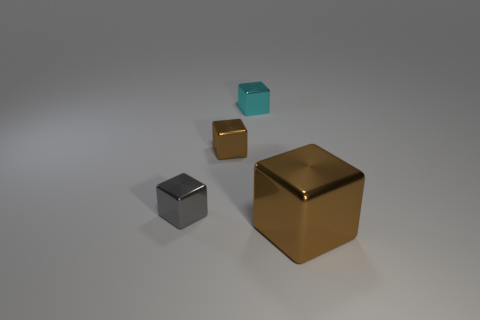What is the color of the cube that is both to the right of the tiny brown cube and behind the tiny gray cube?
Keep it short and to the point. Cyan. Are there any brown blocks of the same size as the gray thing?
Offer a very short reply. Yes. What size is the brown metal thing that is on the left side of the small thing that is behind the small brown metal cube?
Make the answer very short. Small. Are there fewer small brown objects on the right side of the cyan thing than large purple things?
Provide a short and direct response. No. How big is the cyan cube?
Make the answer very short. Small. How many other big objects are the same color as the large shiny thing?
Ensure brevity in your answer.  0. There is a brown metal block that is left of the brown block in front of the gray shiny object; is there a cube left of it?
Provide a short and direct response. Yes. What is the shape of the gray object that is the same size as the cyan object?
Offer a terse response. Cube. How many big things are cyan metal blocks or metal blocks?
Keep it short and to the point. 1. The big block that is made of the same material as the tiny cyan cube is what color?
Keep it short and to the point. Brown. 